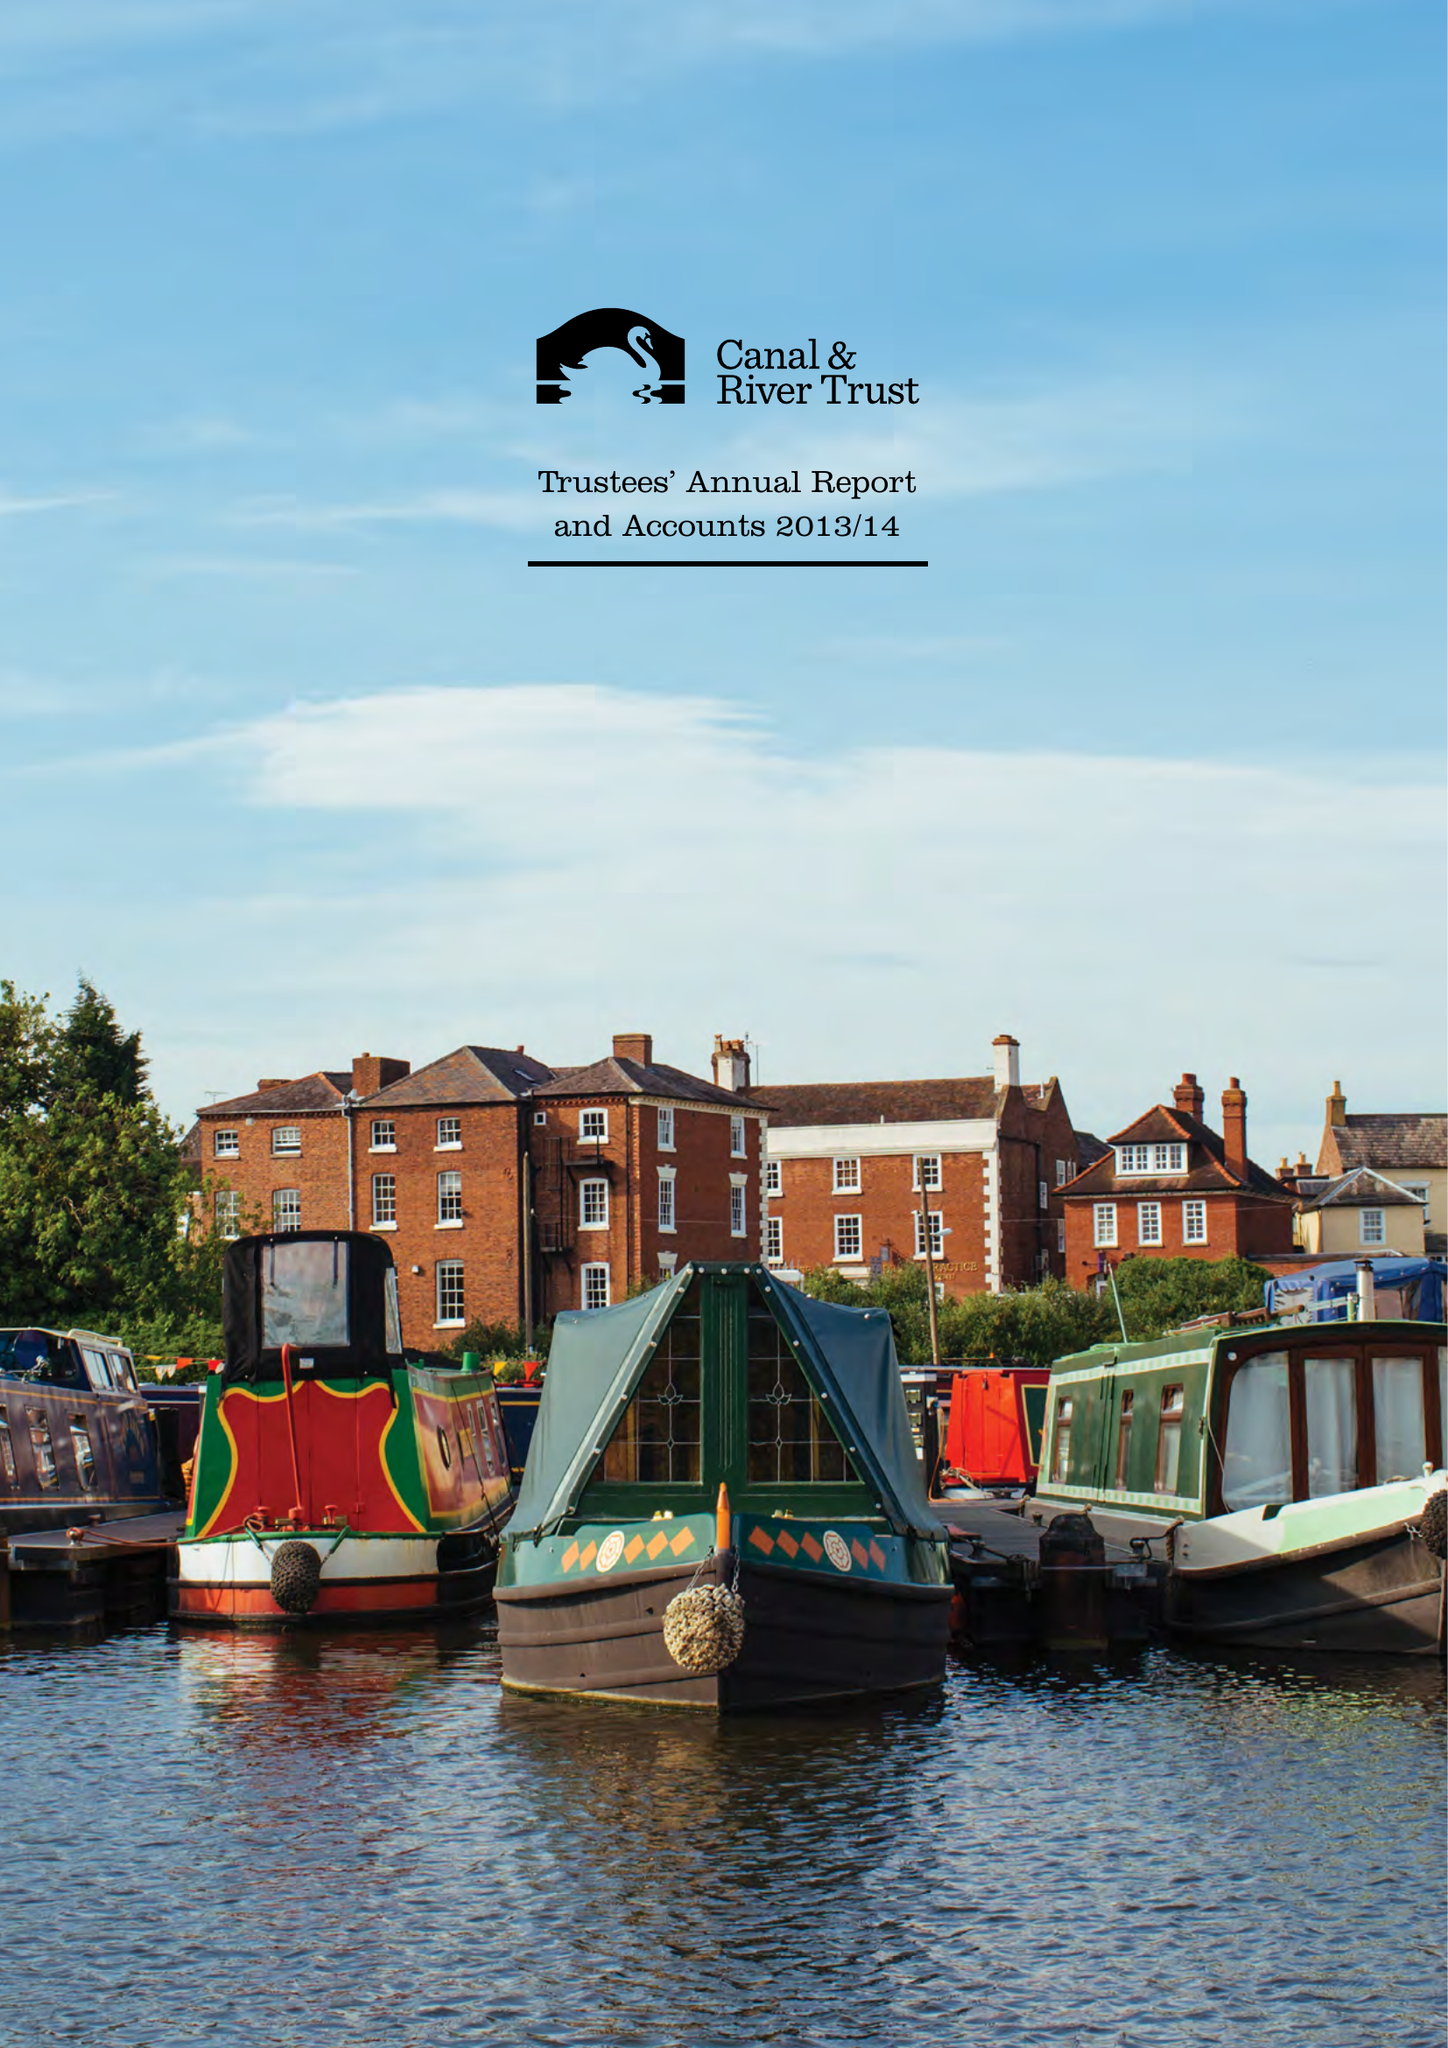What is the value for the charity_name?
Answer the question using a single word or phrase. Canal and River Trust 